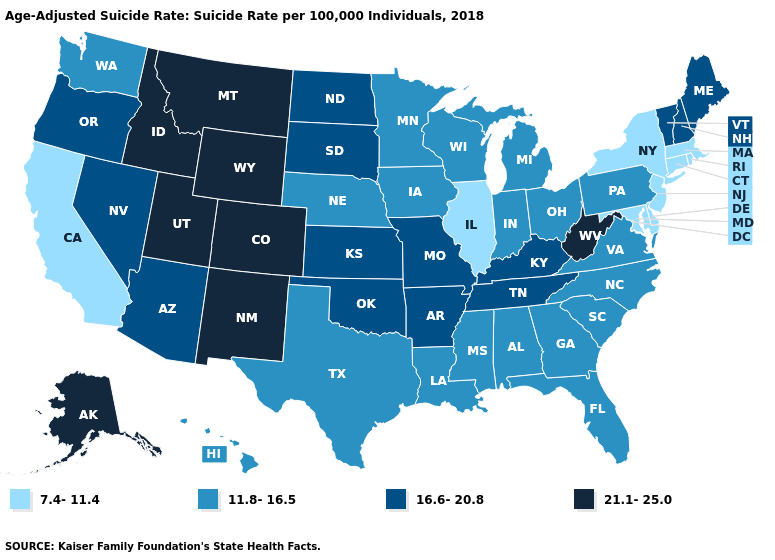Which states have the highest value in the USA?
Write a very short answer. Alaska, Colorado, Idaho, Montana, New Mexico, Utah, West Virginia, Wyoming. How many symbols are there in the legend?
Quick response, please. 4. What is the value of Mississippi?
Give a very brief answer. 11.8-16.5. Name the states that have a value in the range 16.6-20.8?
Answer briefly. Arizona, Arkansas, Kansas, Kentucky, Maine, Missouri, Nevada, New Hampshire, North Dakota, Oklahoma, Oregon, South Dakota, Tennessee, Vermont. Name the states that have a value in the range 11.8-16.5?
Quick response, please. Alabama, Florida, Georgia, Hawaii, Indiana, Iowa, Louisiana, Michigan, Minnesota, Mississippi, Nebraska, North Carolina, Ohio, Pennsylvania, South Carolina, Texas, Virginia, Washington, Wisconsin. Does the first symbol in the legend represent the smallest category?
Give a very brief answer. Yes. Does Indiana have the highest value in the MidWest?
Concise answer only. No. Does Arizona have the highest value in the West?
Keep it brief. No. Does Minnesota have the highest value in the USA?
Short answer required. No. Is the legend a continuous bar?
Concise answer only. No. Which states have the lowest value in the Northeast?
Answer briefly. Connecticut, Massachusetts, New Jersey, New York, Rhode Island. What is the lowest value in the USA?
Quick response, please. 7.4-11.4. What is the value of Arizona?
Keep it brief. 16.6-20.8. Name the states that have a value in the range 21.1-25.0?
Concise answer only. Alaska, Colorado, Idaho, Montana, New Mexico, Utah, West Virginia, Wyoming. Name the states that have a value in the range 11.8-16.5?
Write a very short answer. Alabama, Florida, Georgia, Hawaii, Indiana, Iowa, Louisiana, Michigan, Minnesota, Mississippi, Nebraska, North Carolina, Ohio, Pennsylvania, South Carolina, Texas, Virginia, Washington, Wisconsin. 